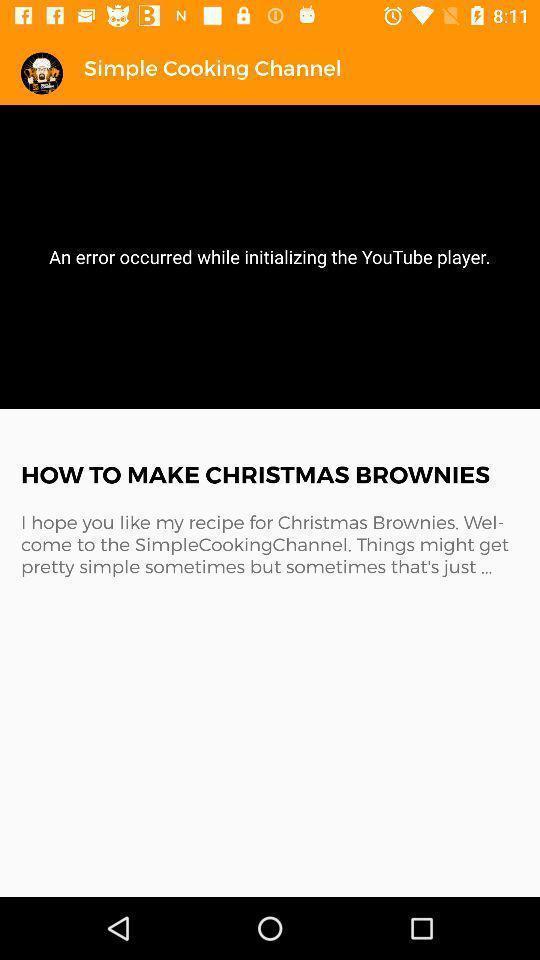Describe the visual elements of this screenshot. Page showing content in a coking based app. 